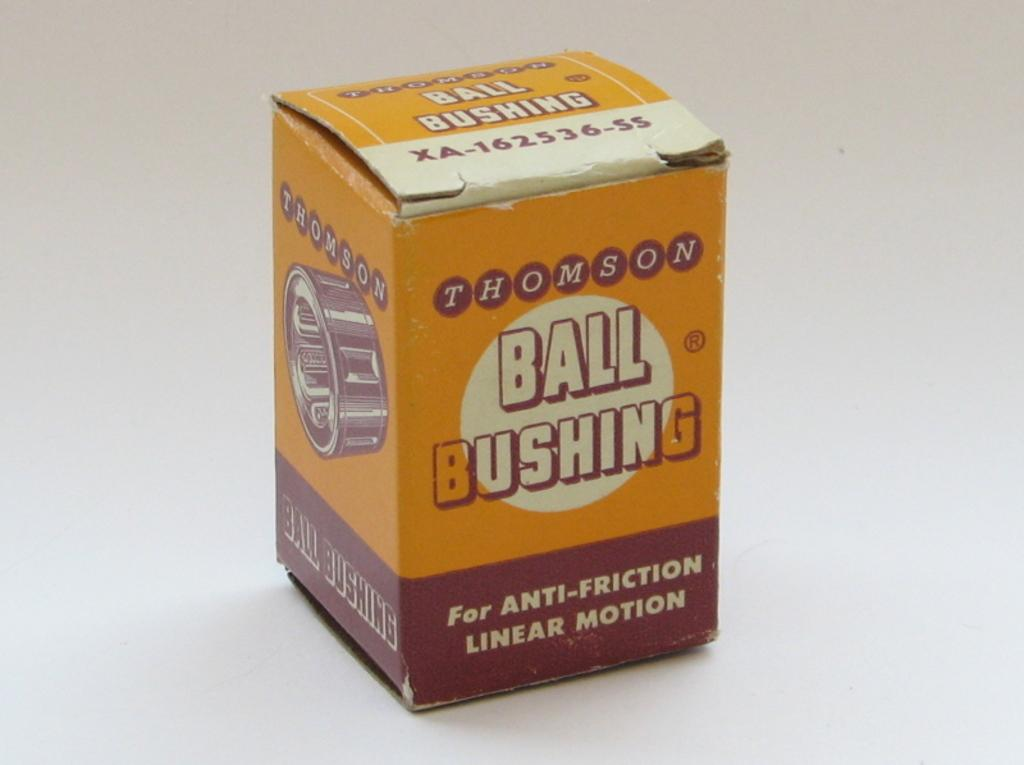<image>
Render a clear and concise summary of the photo. A Thomson Ball bushing for anti-friction linear motion. 